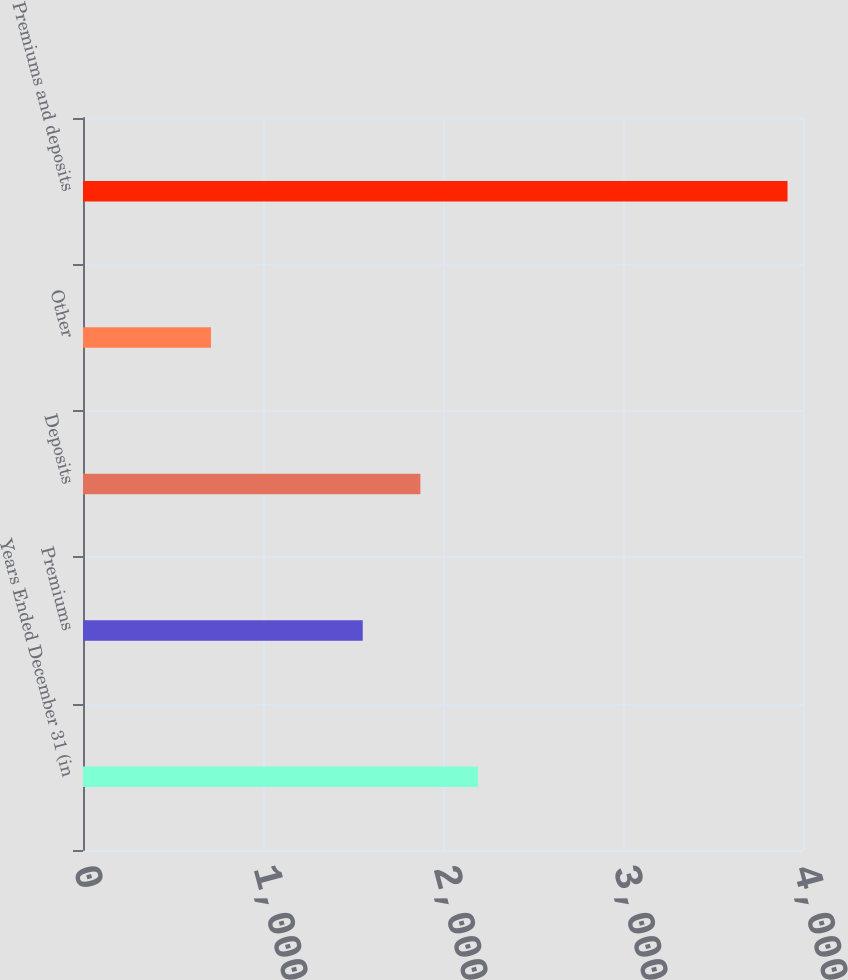Convert chart to OTSL. <chart><loc_0><loc_0><loc_500><loc_500><bar_chart><fcel>Years Ended December 31 (in<fcel>Premiums<fcel>Deposits<fcel>Other<fcel>Premiums and deposits<nl><fcel>2194.6<fcel>1554<fcel>1874.3<fcel>711<fcel>3914<nl></chart> 